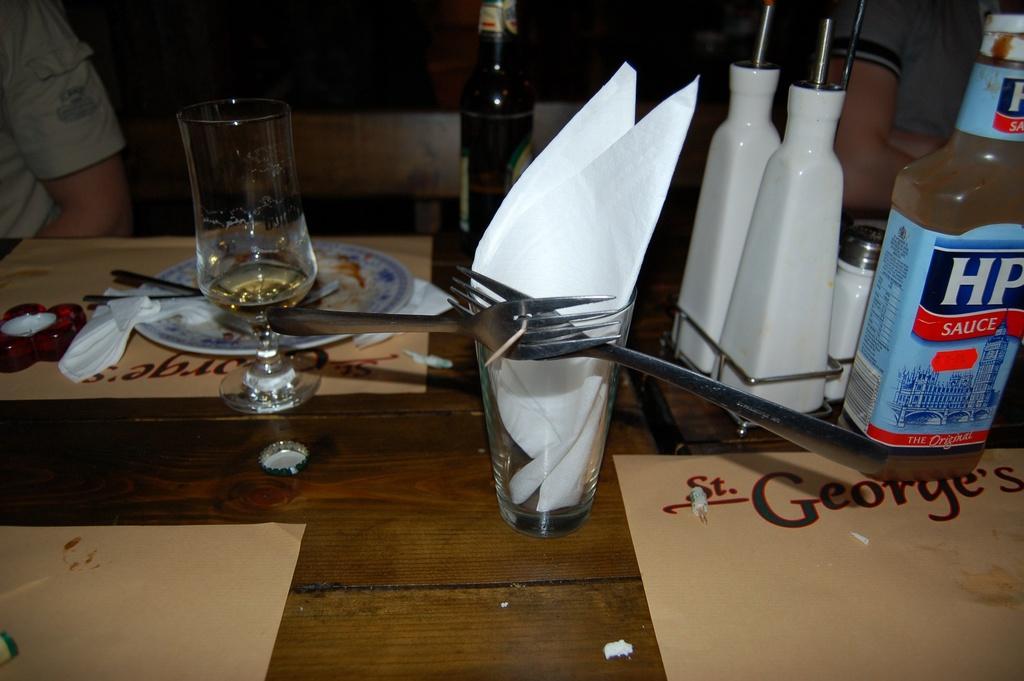Could you give a brief overview of what you see in this image? In this picture we can see a table. On the table there are forks, glasses, plates, and bottles. 